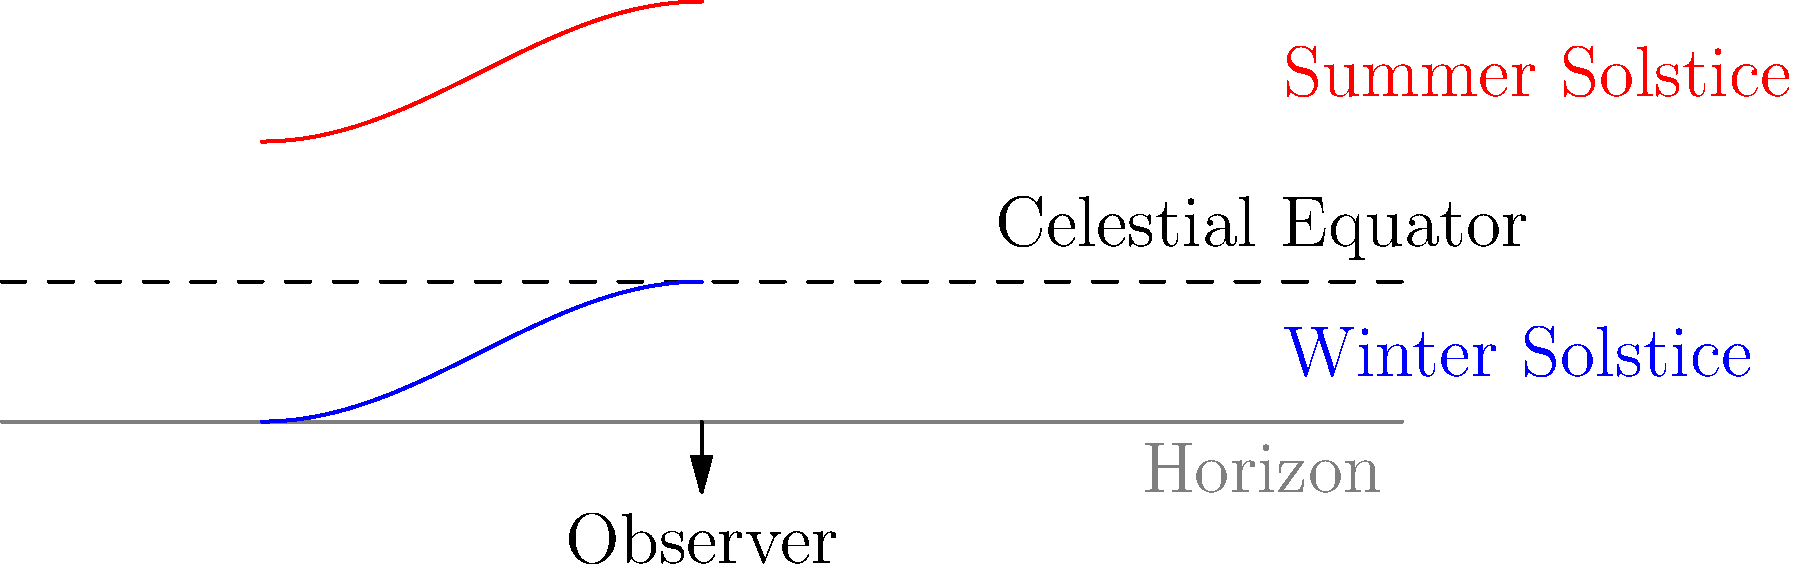As a politician who has often addressed constituents' concerns about daylight hours for various local ordinances, explain how the Sun's path across the sky changes from summer to winter solstice in the Northern Hemisphere. How does this affect the length of daylight hours, and what implications might this have for energy policies? To understand the Sun's path and its implications:

1. Summer Solstice (red path):
   - The Sun's path is higher in the sky
   - It rises and sets further north on the horizon
   - Daylight hours are longest

2. Winter Solstice (blue path):
   - The Sun's path is lower in the sky
   - It rises and sets further south on the horizon
   - Daylight hours are shortest

3. Celestial Equator (dashed line):
   - Represents the Sun's path during equinoxes
   - Equal day and night hours

4. Effects on daylight hours:
   - Summer: Longer days, shorter nights
   - Winter: Shorter days, longer nights

5. Energy policy implications:
   - Summer: Higher cooling demands, potential for solar energy
   - Winter: Higher heating demands, less solar potential
   - Need for seasonal energy management strategies

6. Political considerations:
   - Daylight Saving Time debates
   - School and work schedules
   - Seasonal business regulations
   - Public lighting and safety concerns

Understanding these astronomical patterns is crucial for developing informed policies that address energy consumption, public safety, and economic activities throughout the year.
Answer: The Sun's path is higher and longer in summer, lower and shorter in winter, affecting daylight hours and energy demands, which necessitates adaptive seasonal policies. 